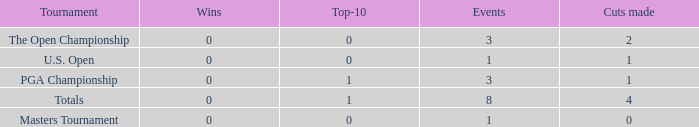For more than 3 events in the PGA Championship, what is the fewest number of wins? None. 